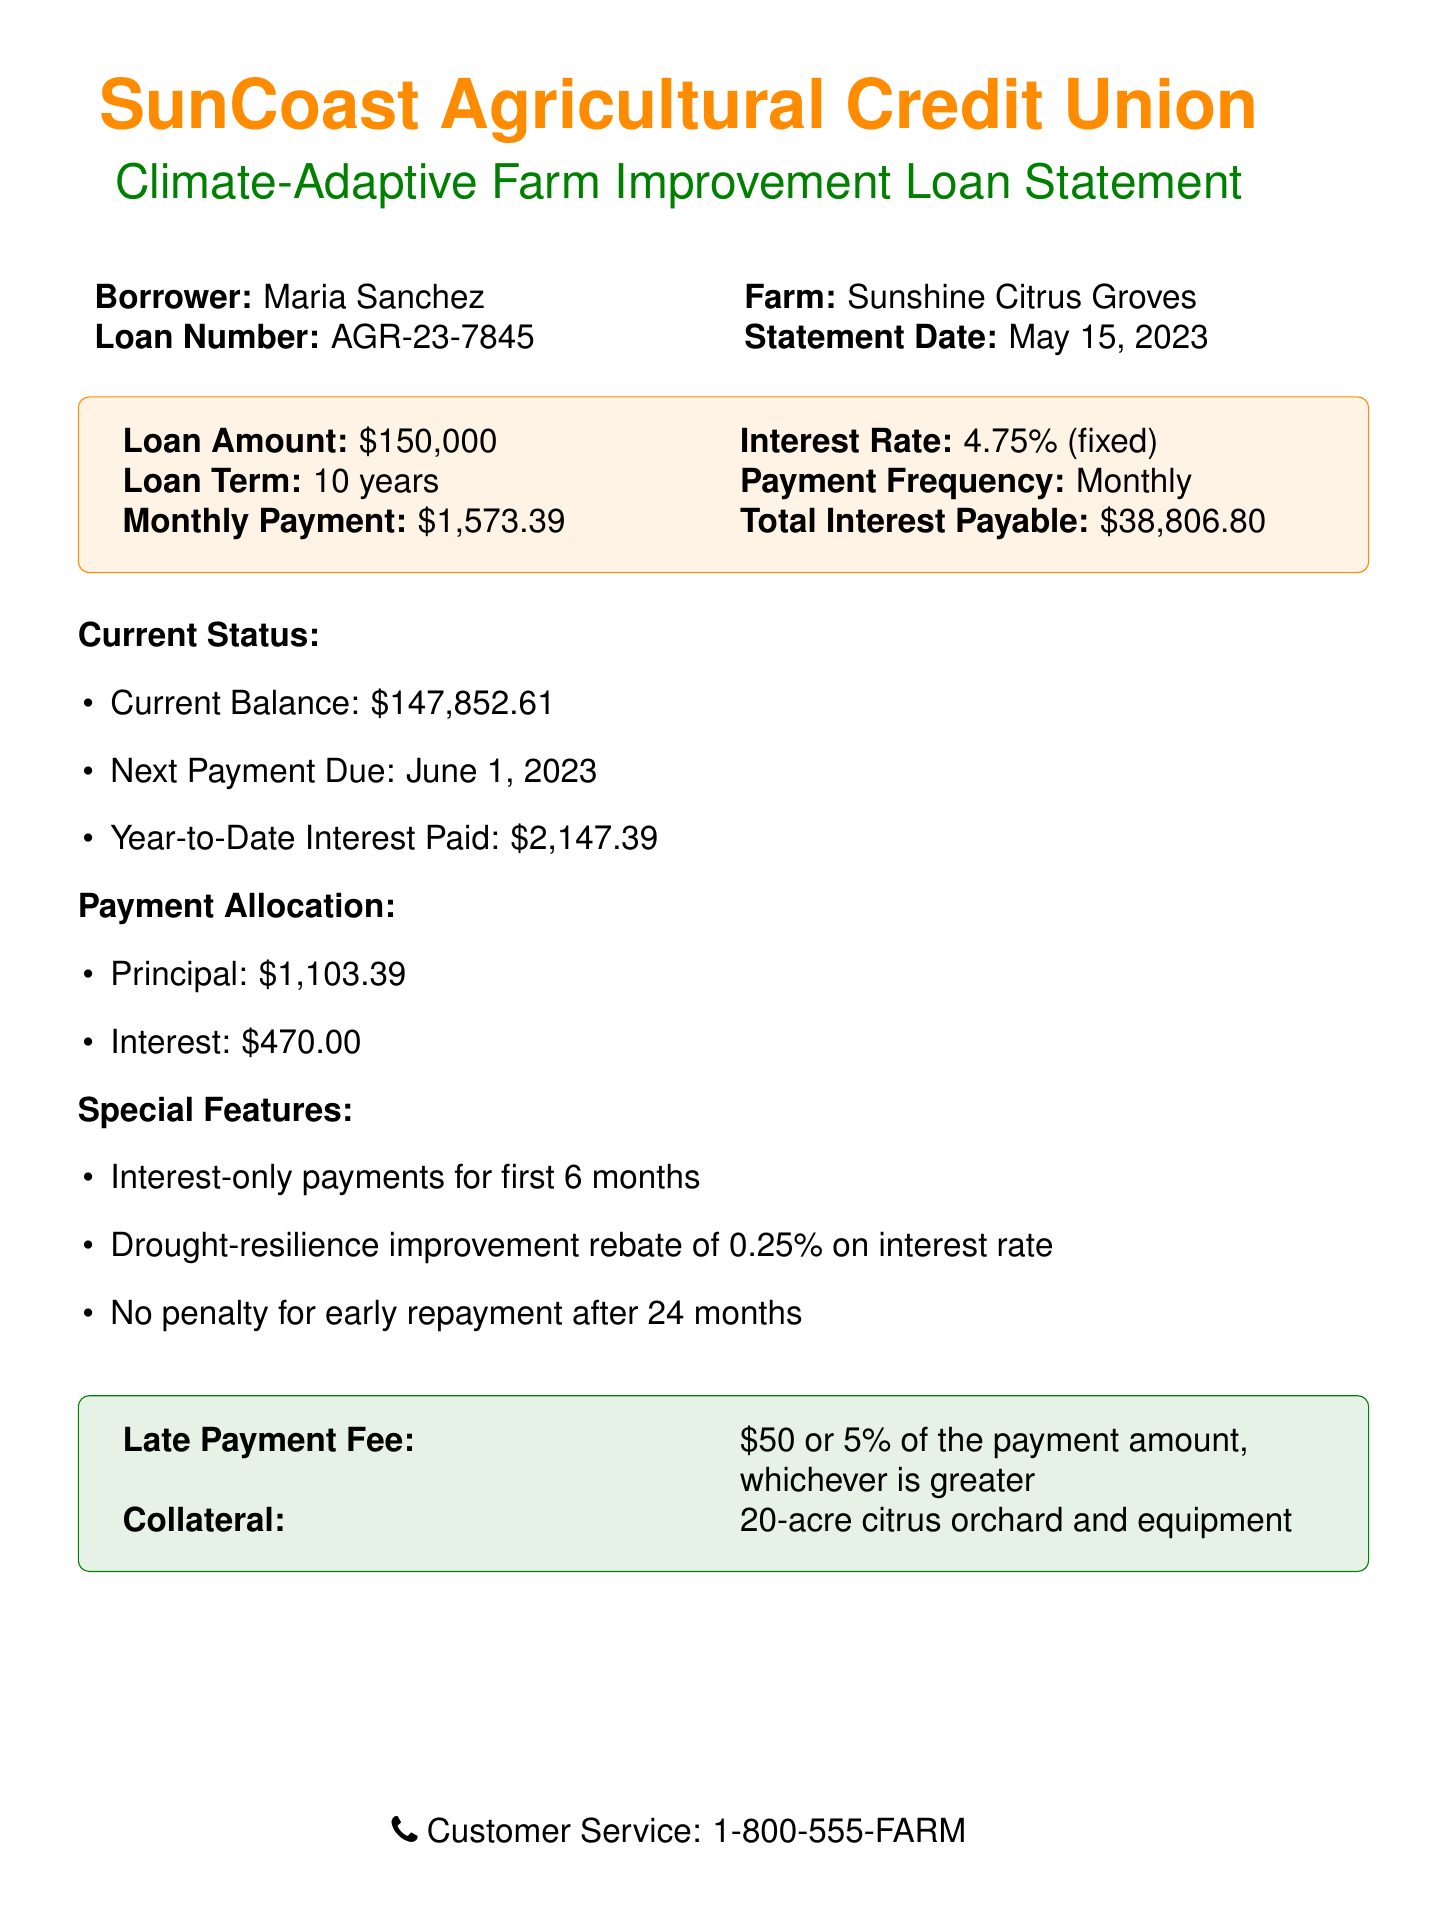What is the loan amount? The loan amount is stated clearly in the document, which is $150,000.
Answer: $150,000 What is the interest rate? The interest rate is specified in the document as 4.75% (fixed).
Answer: 4.75% (fixed) What is the monthly payment? The document lists the monthly payment amount that needs to be paid, which is $1,573.39.
Answer: $1,573.39 When is the next payment due? The document notes the date for the next payment, which is June 1, 2023.
Answer: June 1, 2023 What is the total interest payable? The total interest payable over the loan term is provided in the document as $38,806.80.
Answer: $38,806.80 How long is the loan term? The loan term is mentioned in the document as lasting for 10 years.
Answer: 10 years What percentage rebate is offered for drought-resilience improvement? The document specifies a drought-resilience improvement rebate of 0.25% on the interest rate.
Answer: 0.25% Is there a penalty for early repayment? The document states that there is no penalty for early repayment after 24 months.
Answer: No What is the collateral for the loan? The collateral mentioned in the document is a 20-acre citrus orchard and equipment.
Answer: 20-acre citrus orchard and equipment 